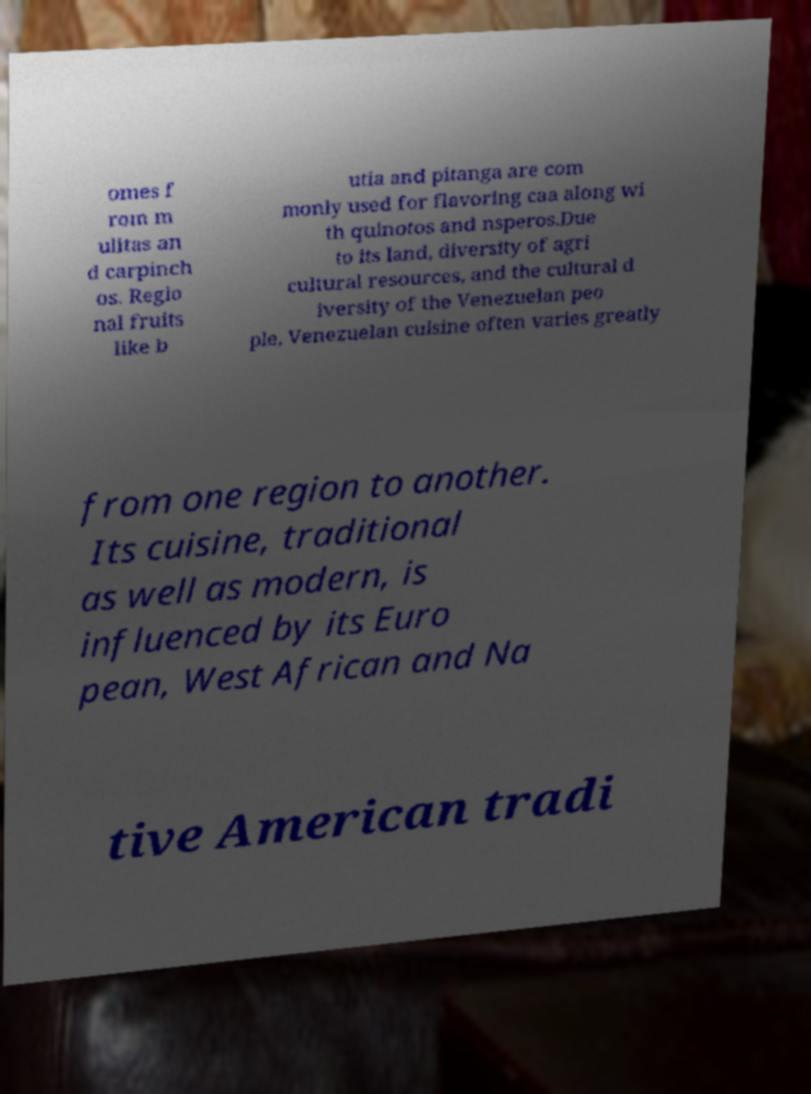There's text embedded in this image that I need extracted. Can you transcribe it verbatim? omes f rom m ulitas an d carpinch os. Regio nal fruits like b utia and pitanga are com monly used for flavoring caa along wi th quinotos and nsperos.Due to its land, diversity of agri cultural resources, and the cultural d iversity of the Venezuelan peo ple, Venezuelan cuisine often varies greatly from one region to another. Its cuisine, traditional as well as modern, is influenced by its Euro pean, West African and Na tive American tradi 